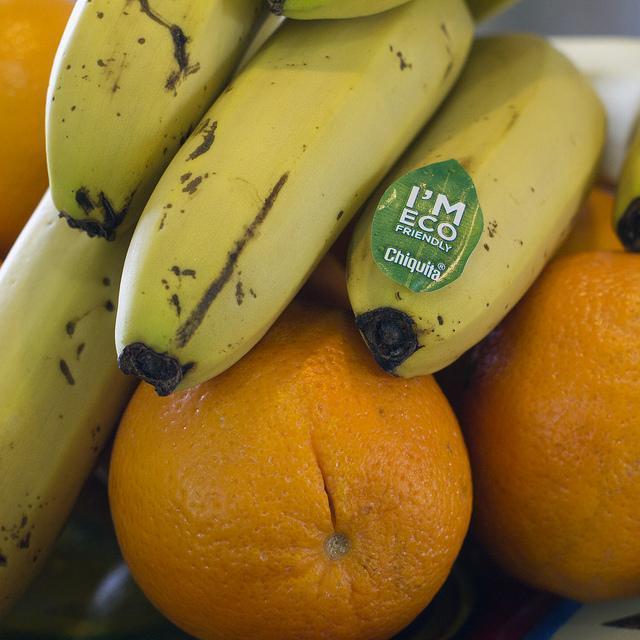How many bananas can be seen?
Give a very brief answer. 5. How many oranges can be seen?
Give a very brief answer. 4. 